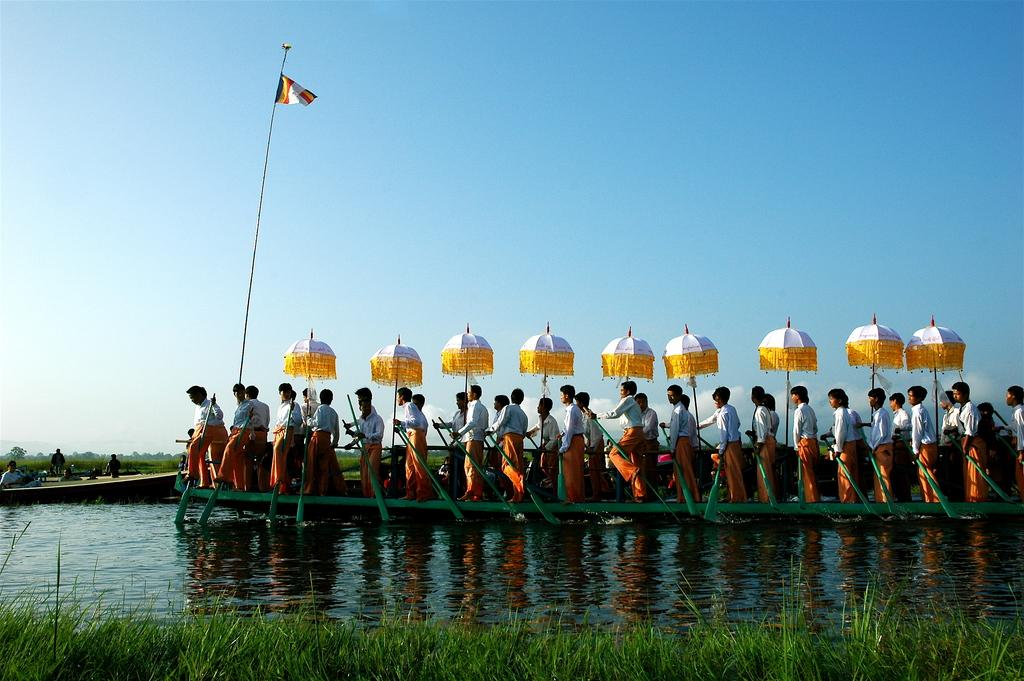What activity are the people in the image engaged in? The people in the image are riding a boat. What type of terrain is visible at the bottom of the image? There is grass and water at the bottom of the image. What is visible at the top of the image? There is sky at the top of the image. What object can be seen in the image that represents a symbol or group? There is a flag in the image. What type of drink is being served in the office in the image? There is no office or drink present in the image; it features people riding a boat with grass, water, sky, and a flag. 